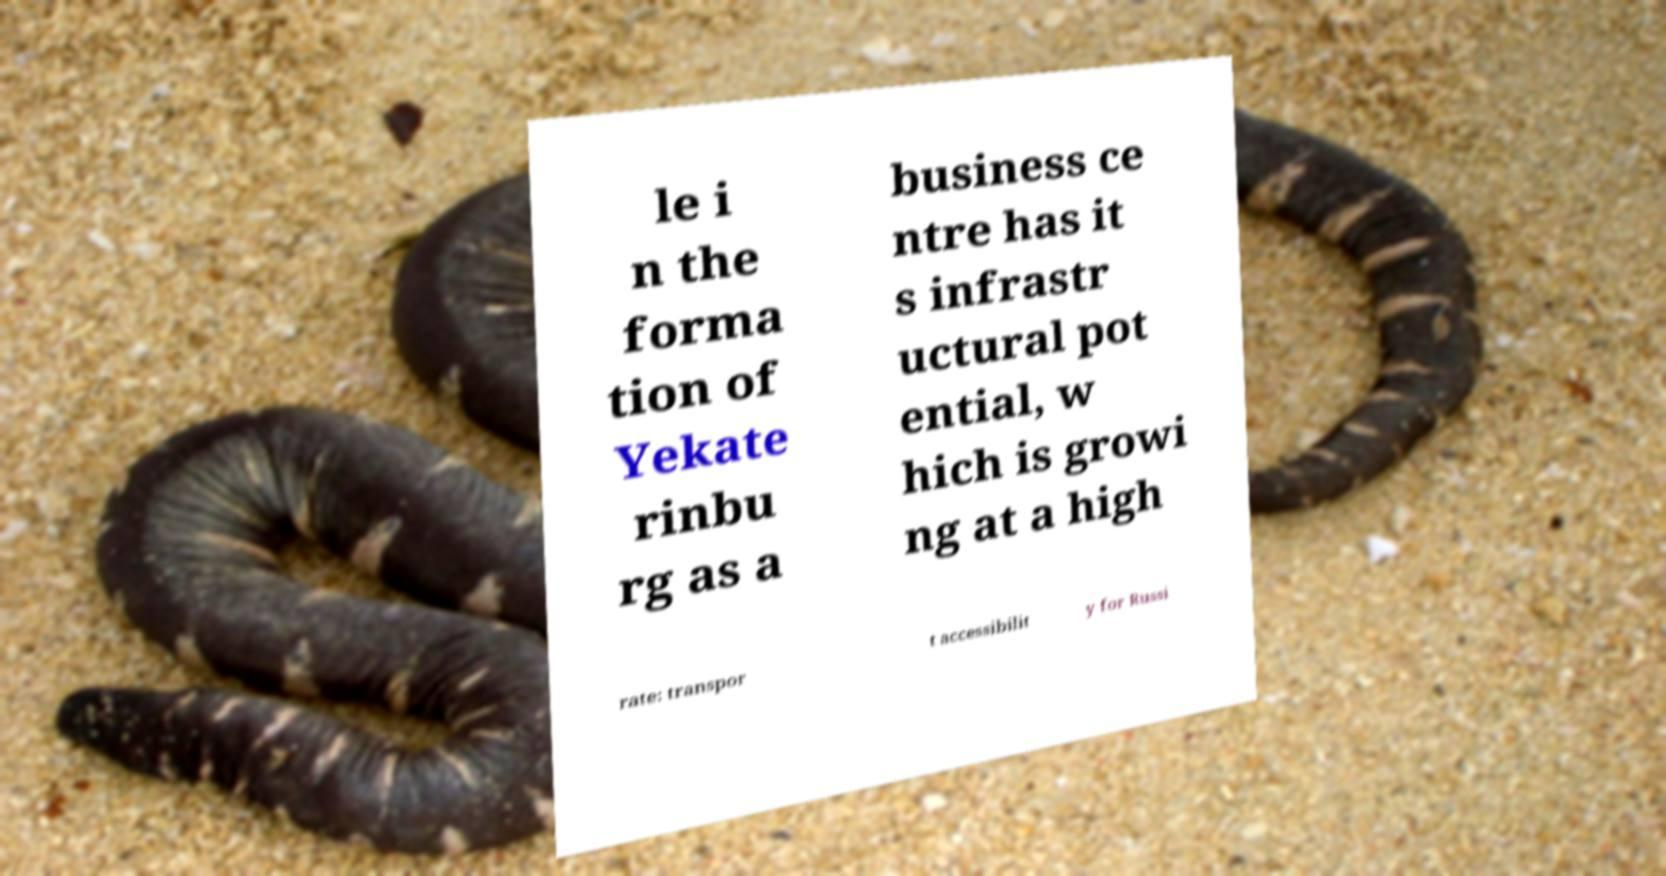For documentation purposes, I need the text within this image transcribed. Could you provide that? le i n the forma tion of Yekate rinbu rg as a business ce ntre has it s infrastr uctural pot ential, w hich is growi ng at a high rate: transpor t accessibilit y for Russi 